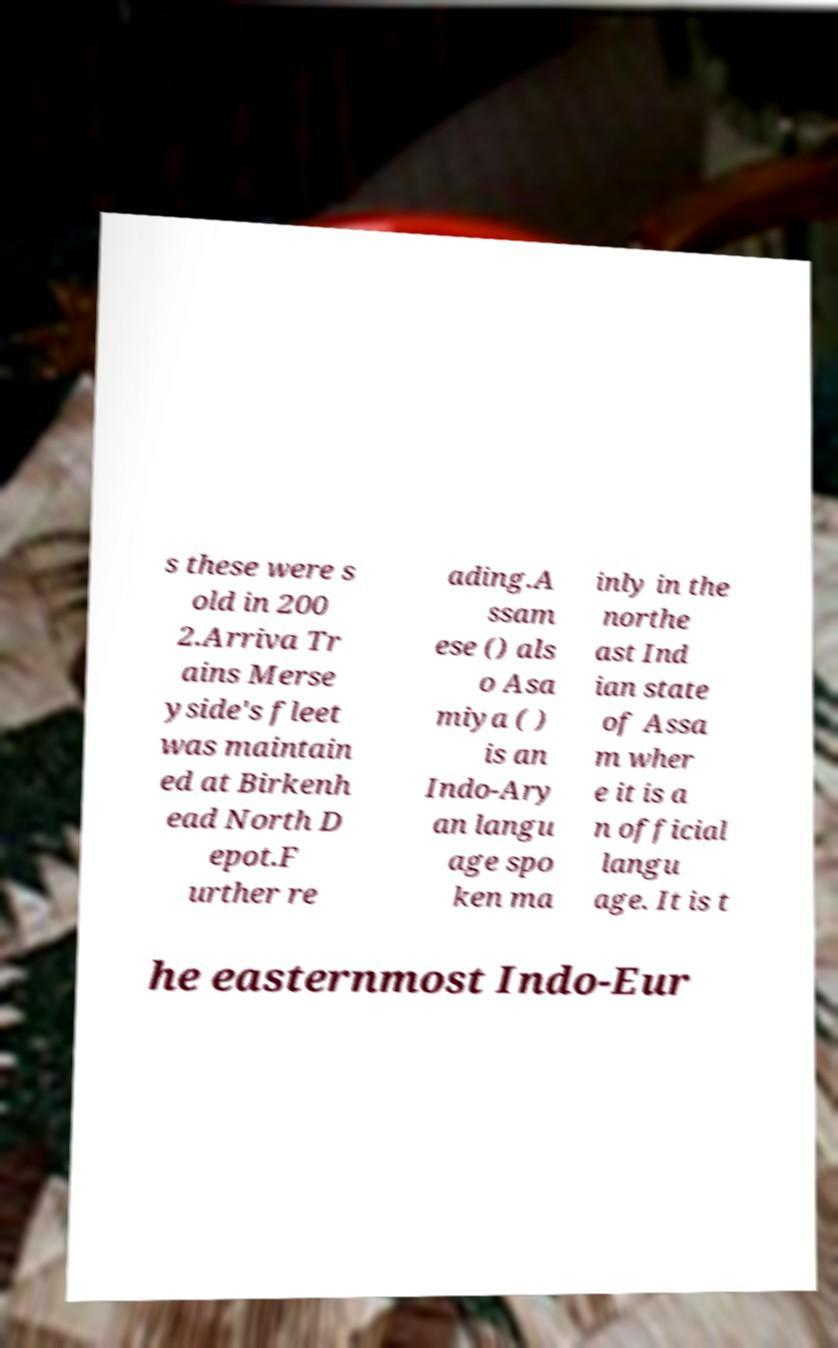Could you extract and type out the text from this image? s these were s old in 200 2.Arriva Tr ains Merse yside's fleet was maintain ed at Birkenh ead North D epot.F urther re ading.A ssam ese () als o Asa miya ( ) is an Indo-Ary an langu age spo ken ma inly in the northe ast Ind ian state of Assa m wher e it is a n official langu age. It is t he easternmost Indo-Eur 